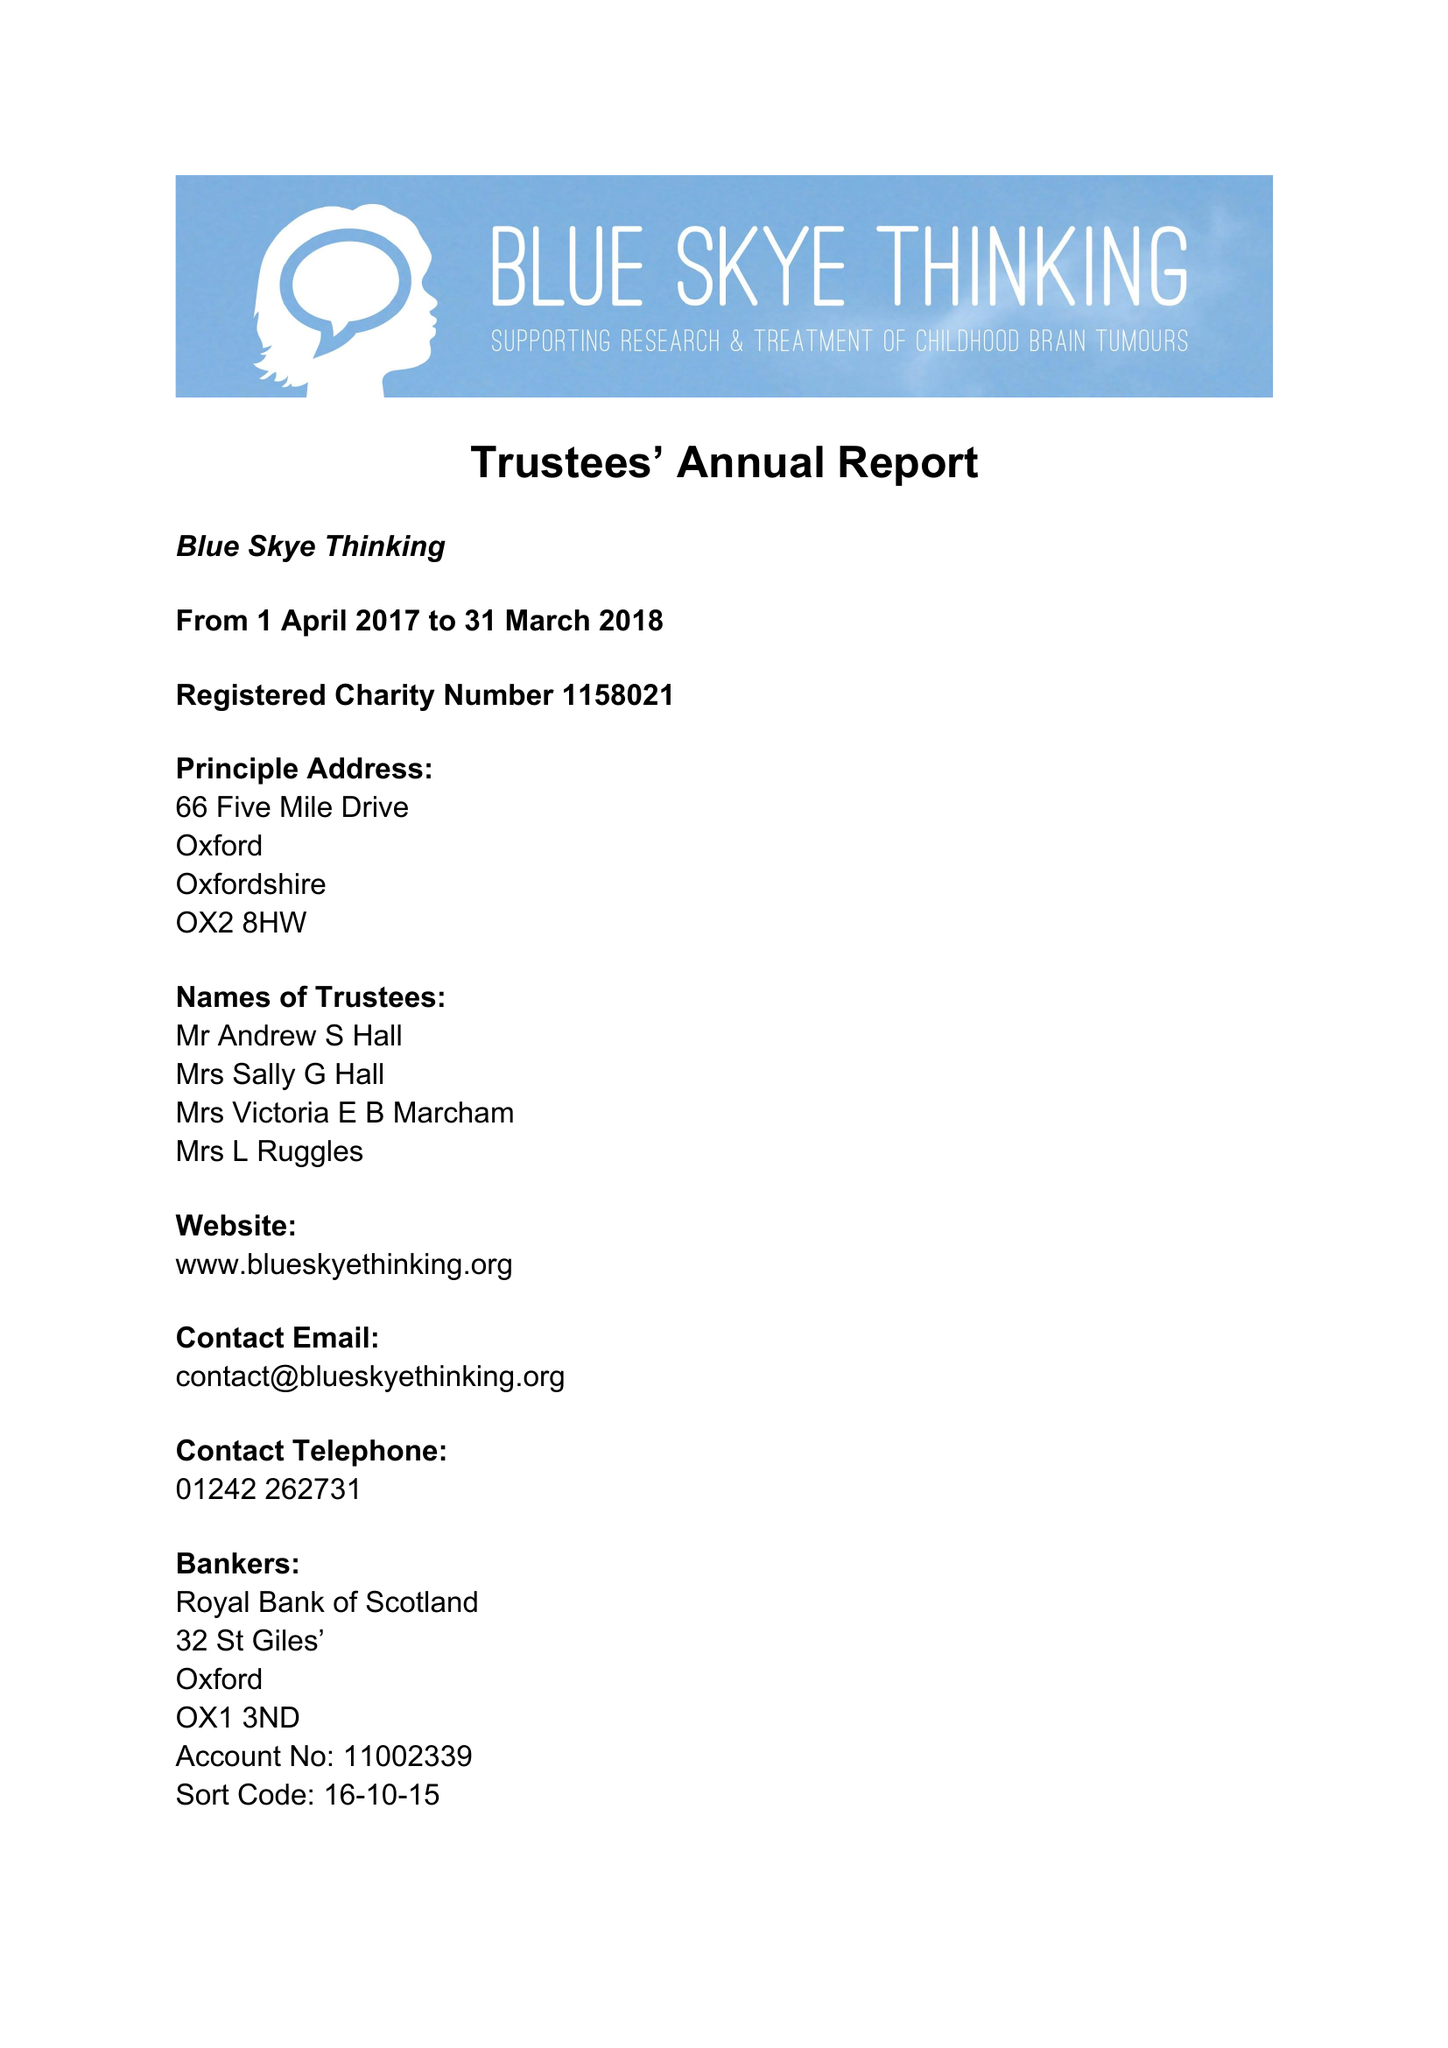What is the value for the income_annually_in_british_pounds?
Answer the question using a single word or phrase. 64115.00 